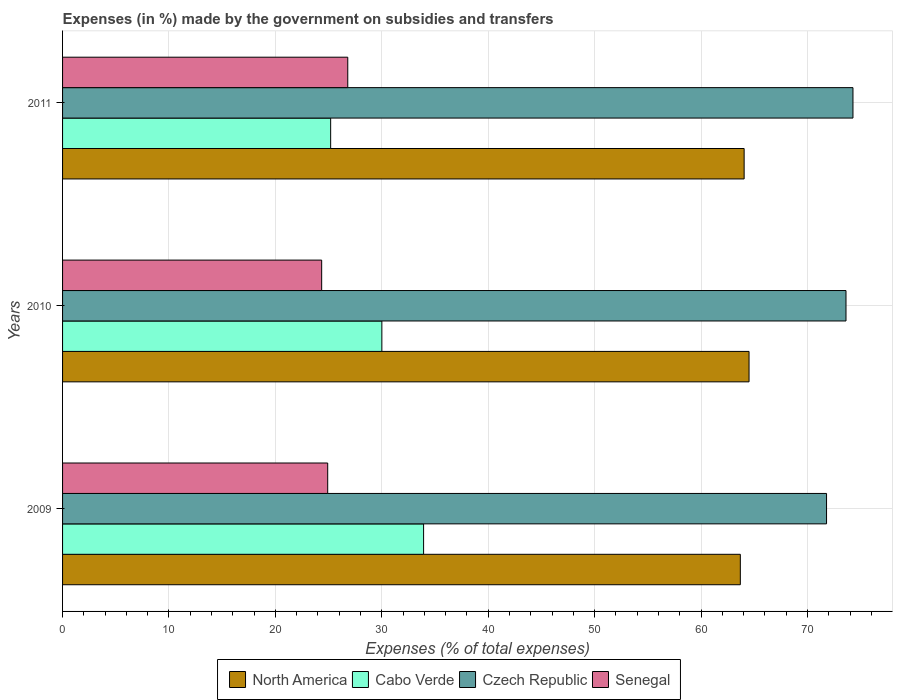How many different coloured bars are there?
Your answer should be compact. 4. How many groups of bars are there?
Ensure brevity in your answer.  3. Are the number of bars per tick equal to the number of legend labels?
Offer a terse response. Yes. What is the percentage of expenses made by the government on subsidies and transfers in Cabo Verde in 2011?
Your response must be concise. 25.19. Across all years, what is the maximum percentage of expenses made by the government on subsidies and transfers in Cabo Verde?
Ensure brevity in your answer.  33.93. Across all years, what is the minimum percentage of expenses made by the government on subsidies and transfers in Czech Republic?
Your answer should be very brief. 71.79. In which year was the percentage of expenses made by the government on subsidies and transfers in Cabo Verde maximum?
Make the answer very short. 2009. In which year was the percentage of expenses made by the government on subsidies and transfers in Czech Republic minimum?
Your answer should be compact. 2009. What is the total percentage of expenses made by the government on subsidies and transfers in Czech Republic in the graph?
Make the answer very short. 219.69. What is the difference between the percentage of expenses made by the government on subsidies and transfers in Cabo Verde in 2009 and that in 2010?
Provide a short and direct response. 3.92. What is the difference between the percentage of expenses made by the government on subsidies and transfers in North America in 2010 and the percentage of expenses made by the government on subsidies and transfers in Czech Republic in 2009?
Your response must be concise. -7.28. What is the average percentage of expenses made by the government on subsidies and transfers in Senegal per year?
Offer a very short reply. 25.35. In the year 2009, what is the difference between the percentage of expenses made by the government on subsidies and transfers in Senegal and percentage of expenses made by the government on subsidies and transfers in Czech Republic?
Ensure brevity in your answer.  -46.88. What is the ratio of the percentage of expenses made by the government on subsidies and transfers in Cabo Verde in 2009 to that in 2010?
Your answer should be compact. 1.13. Is the percentage of expenses made by the government on subsidies and transfers in Cabo Verde in 2009 less than that in 2010?
Ensure brevity in your answer.  No. Is the difference between the percentage of expenses made by the government on subsidies and transfers in Senegal in 2009 and 2011 greater than the difference between the percentage of expenses made by the government on subsidies and transfers in Czech Republic in 2009 and 2011?
Give a very brief answer. Yes. What is the difference between the highest and the second highest percentage of expenses made by the government on subsidies and transfers in Senegal?
Give a very brief answer. 1.89. What is the difference between the highest and the lowest percentage of expenses made by the government on subsidies and transfers in Czech Republic?
Offer a very short reply. 2.48. What does the 1st bar from the top in 2009 represents?
Ensure brevity in your answer.  Senegal. Are all the bars in the graph horizontal?
Give a very brief answer. Yes. Are the values on the major ticks of X-axis written in scientific E-notation?
Make the answer very short. No. Does the graph contain grids?
Offer a very short reply. Yes. How many legend labels are there?
Your answer should be very brief. 4. How are the legend labels stacked?
Your answer should be compact. Horizontal. What is the title of the graph?
Provide a succinct answer. Expenses (in %) made by the government on subsidies and transfers. What is the label or title of the X-axis?
Make the answer very short. Expenses (% of total expenses). What is the Expenses (% of total expenses) in North America in 2009?
Ensure brevity in your answer.  63.69. What is the Expenses (% of total expenses) of Cabo Verde in 2009?
Keep it short and to the point. 33.93. What is the Expenses (% of total expenses) of Czech Republic in 2009?
Provide a short and direct response. 71.79. What is the Expenses (% of total expenses) in Senegal in 2009?
Make the answer very short. 24.91. What is the Expenses (% of total expenses) of North America in 2010?
Your answer should be compact. 64.51. What is the Expenses (% of total expenses) of Cabo Verde in 2010?
Offer a very short reply. 30. What is the Expenses (% of total expenses) in Czech Republic in 2010?
Provide a short and direct response. 73.62. What is the Expenses (% of total expenses) of Senegal in 2010?
Keep it short and to the point. 24.35. What is the Expenses (% of total expenses) of North America in 2011?
Offer a very short reply. 64.05. What is the Expenses (% of total expenses) in Cabo Verde in 2011?
Make the answer very short. 25.19. What is the Expenses (% of total expenses) in Czech Republic in 2011?
Offer a terse response. 74.27. What is the Expenses (% of total expenses) in Senegal in 2011?
Your answer should be compact. 26.8. Across all years, what is the maximum Expenses (% of total expenses) of North America?
Offer a very short reply. 64.51. Across all years, what is the maximum Expenses (% of total expenses) of Cabo Verde?
Keep it short and to the point. 33.93. Across all years, what is the maximum Expenses (% of total expenses) of Czech Republic?
Your answer should be very brief. 74.27. Across all years, what is the maximum Expenses (% of total expenses) in Senegal?
Your answer should be very brief. 26.8. Across all years, what is the minimum Expenses (% of total expenses) in North America?
Your response must be concise. 63.69. Across all years, what is the minimum Expenses (% of total expenses) of Cabo Verde?
Ensure brevity in your answer.  25.19. Across all years, what is the minimum Expenses (% of total expenses) in Czech Republic?
Provide a short and direct response. 71.79. Across all years, what is the minimum Expenses (% of total expenses) of Senegal?
Provide a succinct answer. 24.35. What is the total Expenses (% of total expenses) of North America in the graph?
Provide a succinct answer. 192.25. What is the total Expenses (% of total expenses) in Cabo Verde in the graph?
Offer a terse response. 89.12. What is the total Expenses (% of total expenses) of Czech Republic in the graph?
Ensure brevity in your answer.  219.69. What is the total Expenses (% of total expenses) in Senegal in the graph?
Your answer should be compact. 76.06. What is the difference between the Expenses (% of total expenses) in North America in 2009 and that in 2010?
Provide a short and direct response. -0.82. What is the difference between the Expenses (% of total expenses) in Cabo Verde in 2009 and that in 2010?
Offer a terse response. 3.92. What is the difference between the Expenses (% of total expenses) in Czech Republic in 2009 and that in 2010?
Give a very brief answer. -1.83. What is the difference between the Expenses (% of total expenses) in Senegal in 2009 and that in 2010?
Provide a short and direct response. 0.57. What is the difference between the Expenses (% of total expenses) of North America in 2009 and that in 2011?
Make the answer very short. -0.36. What is the difference between the Expenses (% of total expenses) of Cabo Verde in 2009 and that in 2011?
Ensure brevity in your answer.  8.73. What is the difference between the Expenses (% of total expenses) of Czech Republic in 2009 and that in 2011?
Offer a very short reply. -2.48. What is the difference between the Expenses (% of total expenses) in Senegal in 2009 and that in 2011?
Keep it short and to the point. -1.89. What is the difference between the Expenses (% of total expenses) in North America in 2010 and that in 2011?
Make the answer very short. 0.46. What is the difference between the Expenses (% of total expenses) of Cabo Verde in 2010 and that in 2011?
Your response must be concise. 4.81. What is the difference between the Expenses (% of total expenses) in Czech Republic in 2010 and that in 2011?
Your answer should be compact. -0.66. What is the difference between the Expenses (% of total expenses) of Senegal in 2010 and that in 2011?
Keep it short and to the point. -2.45. What is the difference between the Expenses (% of total expenses) of North America in 2009 and the Expenses (% of total expenses) of Cabo Verde in 2010?
Offer a very short reply. 33.69. What is the difference between the Expenses (% of total expenses) in North America in 2009 and the Expenses (% of total expenses) in Czech Republic in 2010?
Keep it short and to the point. -9.93. What is the difference between the Expenses (% of total expenses) in North America in 2009 and the Expenses (% of total expenses) in Senegal in 2010?
Provide a short and direct response. 39.34. What is the difference between the Expenses (% of total expenses) in Cabo Verde in 2009 and the Expenses (% of total expenses) in Czech Republic in 2010?
Offer a terse response. -39.69. What is the difference between the Expenses (% of total expenses) in Cabo Verde in 2009 and the Expenses (% of total expenses) in Senegal in 2010?
Ensure brevity in your answer.  9.58. What is the difference between the Expenses (% of total expenses) in Czech Republic in 2009 and the Expenses (% of total expenses) in Senegal in 2010?
Offer a very short reply. 47.44. What is the difference between the Expenses (% of total expenses) of North America in 2009 and the Expenses (% of total expenses) of Cabo Verde in 2011?
Your response must be concise. 38.5. What is the difference between the Expenses (% of total expenses) of North America in 2009 and the Expenses (% of total expenses) of Czech Republic in 2011?
Make the answer very short. -10.59. What is the difference between the Expenses (% of total expenses) of North America in 2009 and the Expenses (% of total expenses) of Senegal in 2011?
Your answer should be very brief. 36.89. What is the difference between the Expenses (% of total expenses) of Cabo Verde in 2009 and the Expenses (% of total expenses) of Czech Republic in 2011?
Offer a terse response. -40.35. What is the difference between the Expenses (% of total expenses) of Cabo Verde in 2009 and the Expenses (% of total expenses) of Senegal in 2011?
Your answer should be compact. 7.12. What is the difference between the Expenses (% of total expenses) of Czech Republic in 2009 and the Expenses (% of total expenses) of Senegal in 2011?
Give a very brief answer. 44.99. What is the difference between the Expenses (% of total expenses) of North America in 2010 and the Expenses (% of total expenses) of Cabo Verde in 2011?
Your answer should be compact. 39.32. What is the difference between the Expenses (% of total expenses) in North America in 2010 and the Expenses (% of total expenses) in Czech Republic in 2011?
Provide a short and direct response. -9.77. What is the difference between the Expenses (% of total expenses) in North America in 2010 and the Expenses (% of total expenses) in Senegal in 2011?
Keep it short and to the point. 37.71. What is the difference between the Expenses (% of total expenses) in Cabo Verde in 2010 and the Expenses (% of total expenses) in Czech Republic in 2011?
Your response must be concise. -44.27. What is the difference between the Expenses (% of total expenses) in Cabo Verde in 2010 and the Expenses (% of total expenses) in Senegal in 2011?
Offer a terse response. 3.2. What is the difference between the Expenses (% of total expenses) in Czech Republic in 2010 and the Expenses (% of total expenses) in Senegal in 2011?
Offer a terse response. 46.82. What is the average Expenses (% of total expenses) in North America per year?
Ensure brevity in your answer.  64.08. What is the average Expenses (% of total expenses) in Cabo Verde per year?
Your response must be concise. 29.71. What is the average Expenses (% of total expenses) of Czech Republic per year?
Provide a short and direct response. 73.23. What is the average Expenses (% of total expenses) in Senegal per year?
Your answer should be compact. 25.35. In the year 2009, what is the difference between the Expenses (% of total expenses) of North America and Expenses (% of total expenses) of Cabo Verde?
Give a very brief answer. 29.76. In the year 2009, what is the difference between the Expenses (% of total expenses) in North America and Expenses (% of total expenses) in Czech Republic?
Offer a terse response. -8.1. In the year 2009, what is the difference between the Expenses (% of total expenses) in North America and Expenses (% of total expenses) in Senegal?
Keep it short and to the point. 38.77. In the year 2009, what is the difference between the Expenses (% of total expenses) of Cabo Verde and Expenses (% of total expenses) of Czech Republic?
Offer a terse response. -37.87. In the year 2009, what is the difference between the Expenses (% of total expenses) in Cabo Verde and Expenses (% of total expenses) in Senegal?
Provide a short and direct response. 9.01. In the year 2009, what is the difference between the Expenses (% of total expenses) of Czech Republic and Expenses (% of total expenses) of Senegal?
Offer a very short reply. 46.88. In the year 2010, what is the difference between the Expenses (% of total expenses) of North America and Expenses (% of total expenses) of Cabo Verde?
Make the answer very short. 34.5. In the year 2010, what is the difference between the Expenses (% of total expenses) in North America and Expenses (% of total expenses) in Czech Republic?
Keep it short and to the point. -9.11. In the year 2010, what is the difference between the Expenses (% of total expenses) of North America and Expenses (% of total expenses) of Senegal?
Offer a very short reply. 40.16. In the year 2010, what is the difference between the Expenses (% of total expenses) of Cabo Verde and Expenses (% of total expenses) of Czech Republic?
Offer a very short reply. -43.62. In the year 2010, what is the difference between the Expenses (% of total expenses) in Cabo Verde and Expenses (% of total expenses) in Senegal?
Your answer should be very brief. 5.66. In the year 2010, what is the difference between the Expenses (% of total expenses) of Czech Republic and Expenses (% of total expenses) of Senegal?
Make the answer very short. 49.27. In the year 2011, what is the difference between the Expenses (% of total expenses) in North America and Expenses (% of total expenses) in Cabo Verde?
Make the answer very short. 38.85. In the year 2011, what is the difference between the Expenses (% of total expenses) of North America and Expenses (% of total expenses) of Czech Republic?
Your answer should be compact. -10.23. In the year 2011, what is the difference between the Expenses (% of total expenses) in North America and Expenses (% of total expenses) in Senegal?
Provide a short and direct response. 37.25. In the year 2011, what is the difference between the Expenses (% of total expenses) in Cabo Verde and Expenses (% of total expenses) in Czech Republic?
Your response must be concise. -49.08. In the year 2011, what is the difference between the Expenses (% of total expenses) of Cabo Verde and Expenses (% of total expenses) of Senegal?
Provide a succinct answer. -1.61. In the year 2011, what is the difference between the Expenses (% of total expenses) in Czech Republic and Expenses (% of total expenses) in Senegal?
Ensure brevity in your answer.  47.47. What is the ratio of the Expenses (% of total expenses) of North America in 2009 to that in 2010?
Offer a very short reply. 0.99. What is the ratio of the Expenses (% of total expenses) of Cabo Verde in 2009 to that in 2010?
Offer a very short reply. 1.13. What is the ratio of the Expenses (% of total expenses) in Czech Republic in 2009 to that in 2010?
Give a very brief answer. 0.98. What is the ratio of the Expenses (% of total expenses) in Senegal in 2009 to that in 2010?
Give a very brief answer. 1.02. What is the ratio of the Expenses (% of total expenses) of North America in 2009 to that in 2011?
Give a very brief answer. 0.99. What is the ratio of the Expenses (% of total expenses) of Cabo Verde in 2009 to that in 2011?
Provide a short and direct response. 1.35. What is the ratio of the Expenses (% of total expenses) of Czech Republic in 2009 to that in 2011?
Make the answer very short. 0.97. What is the ratio of the Expenses (% of total expenses) in Senegal in 2009 to that in 2011?
Give a very brief answer. 0.93. What is the ratio of the Expenses (% of total expenses) of Cabo Verde in 2010 to that in 2011?
Provide a succinct answer. 1.19. What is the ratio of the Expenses (% of total expenses) in Senegal in 2010 to that in 2011?
Your answer should be very brief. 0.91. What is the difference between the highest and the second highest Expenses (% of total expenses) in North America?
Give a very brief answer. 0.46. What is the difference between the highest and the second highest Expenses (% of total expenses) in Cabo Verde?
Keep it short and to the point. 3.92. What is the difference between the highest and the second highest Expenses (% of total expenses) of Czech Republic?
Provide a short and direct response. 0.66. What is the difference between the highest and the second highest Expenses (% of total expenses) in Senegal?
Your response must be concise. 1.89. What is the difference between the highest and the lowest Expenses (% of total expenses) of North America?
Your answer should be compact. 0.82. What is the difference between the highest and the lowest Expenses (% of total expenses) in Cabo Verde?
Offer a terse response. 8.73. What is the difference between the highest and the lowest Expenses (% of total expenses) in Czech Republic?
Your response must be concise. 2.48. What is the difference between the highest and the lowest Expenses (% of total expenses) in Senegal?
Provide a succinct answer. 2.45. 